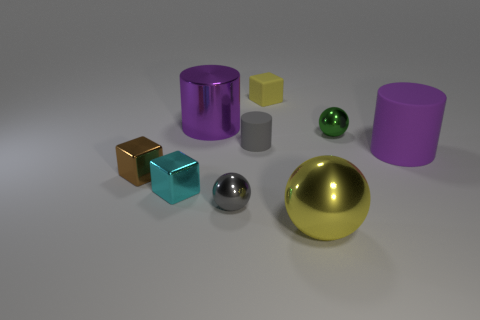Are there any small gray objects left of the small cylinder?
Make the answer very short. Yes. What number of tiny objects are spheres or rubber blocks?
Provide a succinct answer. 3. Is the material of the large yellow thing the same as the yellow cube?
Keep it short and to the point. No. What size is the ball that is the same color as the tiny rubber cube?
Provide a succinct answer. Large. Is there a tiny object that has the same color as the big sphere?
Make the answer very short. Yes. There is a purple cylinder that is made of the same material as the gray ball; what is its size?
Provide a succinct answer. Large. There is a purple thing to the right of the large purple object that is on the left side of the thing in front of the gray shiny ball; what shape is it?
Make the answer very short. Cylinder. What size is the purple metallic thing that is the same shape as the big rubber thing?
Your response must be concise. Large. What is the size of the object that is both behind the green object and in front of the yellow matte object?
Ensure brevity in your answer.  Large. There is a object that is the same color as the big ball; what shape is it?
Give a very brief answer. Cube. 